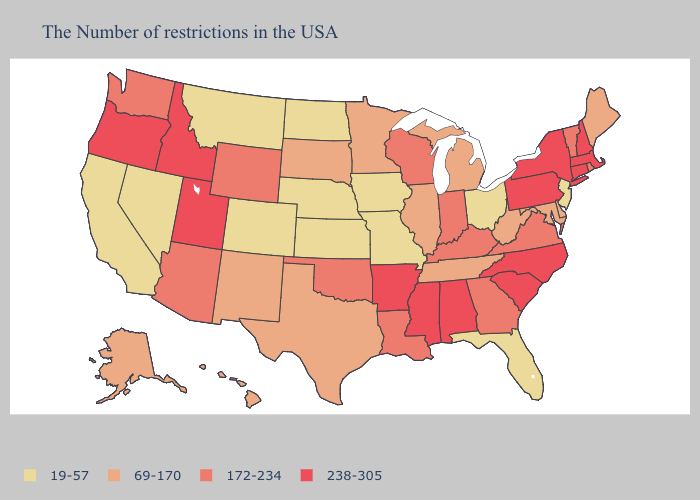What is the highest value in states that border California?
Give a very brief answer. 238-305. What is the highest value in the Northeast ?
Be succinct. 238-305. Among the states that border Indiana , which have the highest value?
Give a very brief answer. Kentucky. What is the highest value in states that border Virginia?
Keep it brief. 238-305. Name the states that have a value in the range 19-57?
Short answer required. New Jersey, Ohio, Florida, Missouri, Iowa, Kansas, Nebraska, North Dakota, Colorado, Montana, Nevada, California. What is the value of New Jersey?
Quick response, please. 19-57. What is the highest value in states that border Ohio?
Be succinct. 238-305. Name the states that have a value in the range 238-305?
Keep it brief. Massachusetts, New Hampshire, Connecticut, New York, Pennsylvania, North Carolina, South Carolina, Alabama, Mississippi, Arkansas, Utah, Idaho, Oregon. Does Idaho have a lower value than Nebraska?
Answer briefly. No. Does the map have missing data?
Answer briefly. No. What is the highest value in states that border Wisconsin?
Be succinct. 69-170. Name the states that have a value in the range 238-305?
Give a very brief answer. Massachusetts, New Hampshire, Connecticut, New York, Pennsylvania, North Carolina, South Carolina, Alabama, Mississippi, Arkansas, Utah, Idaho, Oregon. What is the value of New Mexico?
Give a very brief answer. 69-170. What is the value of California?
Short answer required. 19-57. Does Wyoming have the same value as California?
Keep it brief. No. 